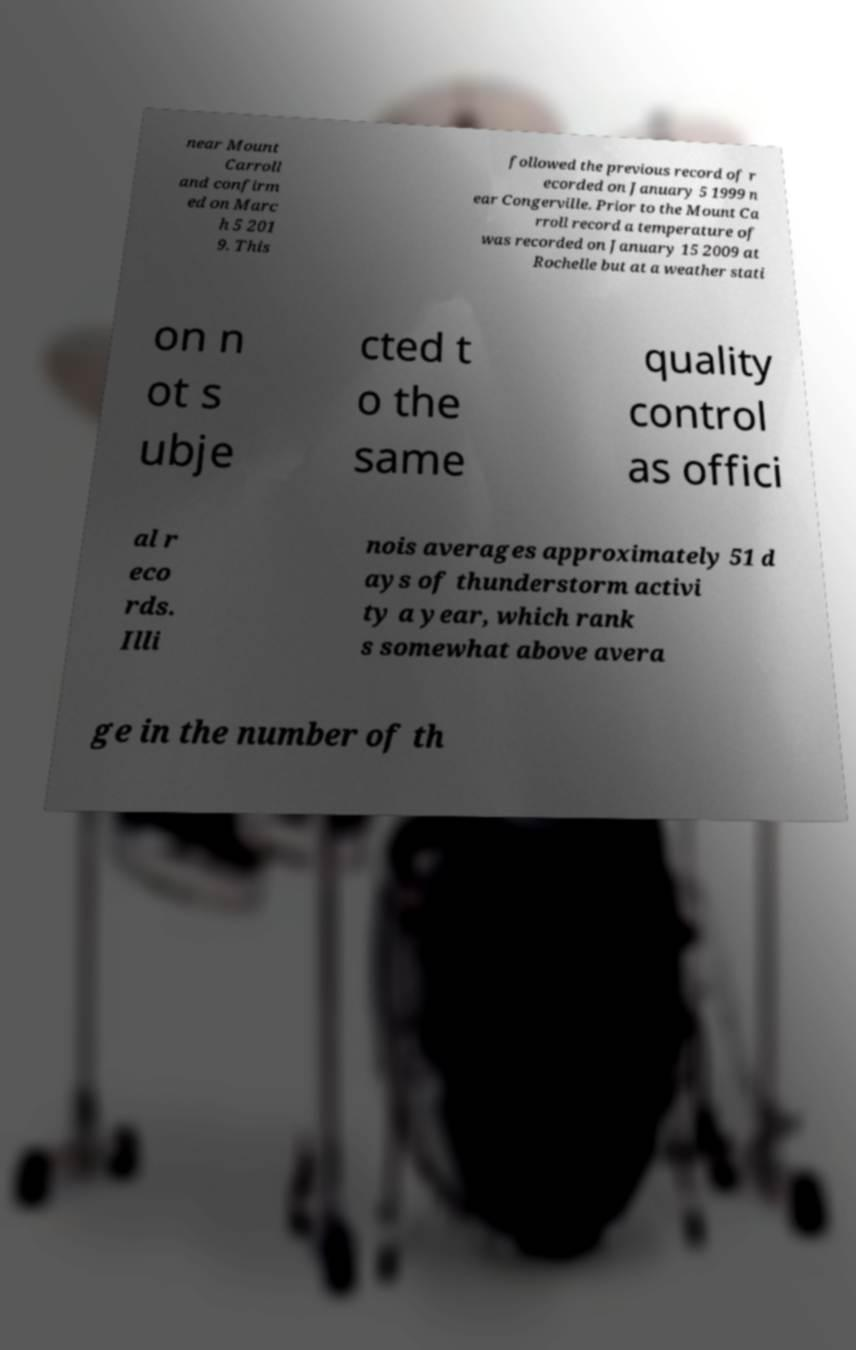What messages or text are displayed in this image? I need them in a readable, typed format. near Mount Carroll and confirm ed on Marc h 5 201 9. This followed the previous record of r ecorded on January 5 1999 n ear Congerville. Prior to the Mount Ca rroll record a temperature of was recorded on January 15 2009 at Rochelle but at a weather stati on n ot s ubje cted t o the same quality control as offici al r eco rds. Illi nois averages approximately 51 d ays of thunderstorm activi ty a year, which rank s somewhat above avera ge in the number of th 